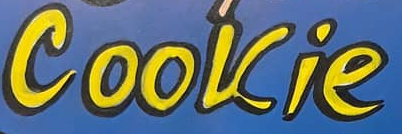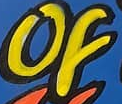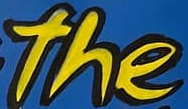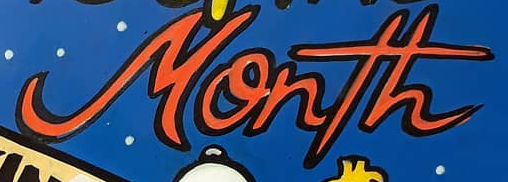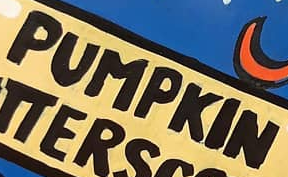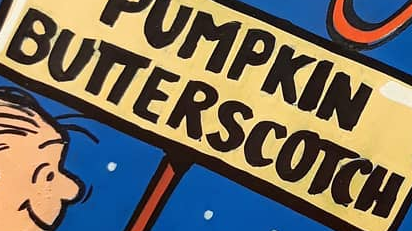What text appears in these images from left to right, separated by a semicolon? Cookie; of; the; Month; PUMPKIN; BUTTERSCOTCH 